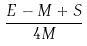<formula> <loc_0><loc_0><loc_500><loc_500>\frac { E - M + S } { 4 M }</formula> 